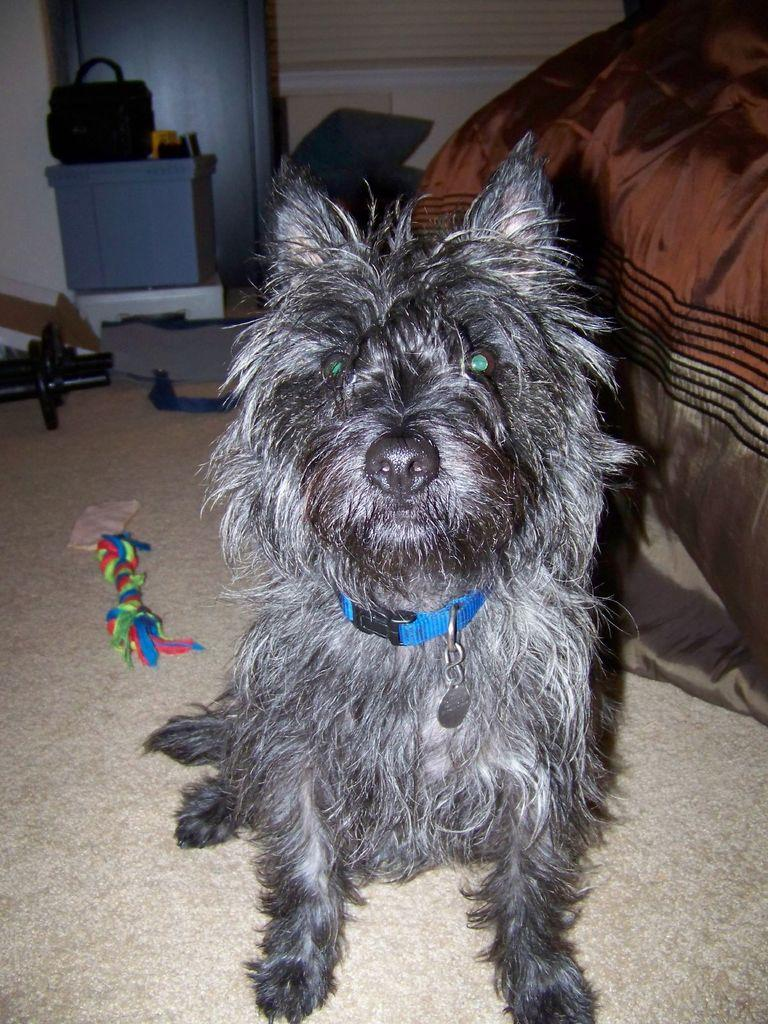What animal is on the floor in the image? There is a dog on the floor in the image. What is located beside the dog? There is a bed beside the dog. Can you describe the object that is far from the dog and bed? There is a container far from the dog and bed. What is hanging above the container? There is a bag above the container. How does the dog attract the attention of the hole in the image? There is no hole present in the image, so the dog cannot attract its attention. 